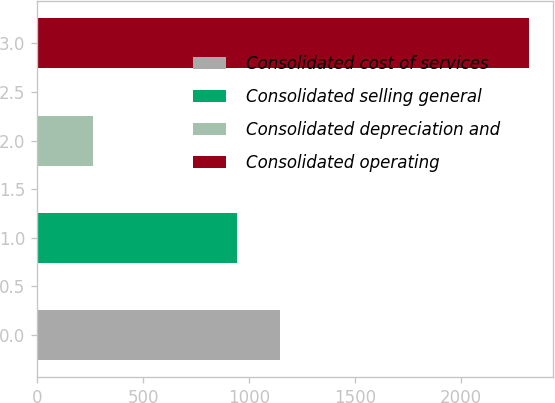Convert chart to OTSL. <chart><loc_0><loc_0><loc_500><loc_500><bar_chart><fcel>Consolidated cost of services<fcel>Consolidated selling general<fcel>Consolidated depreciation and<fcel>Consolidated operating<nl><fcel>1146.44<fcel>941<fcel>265.4<fcel>2319.8<nl></chart> 